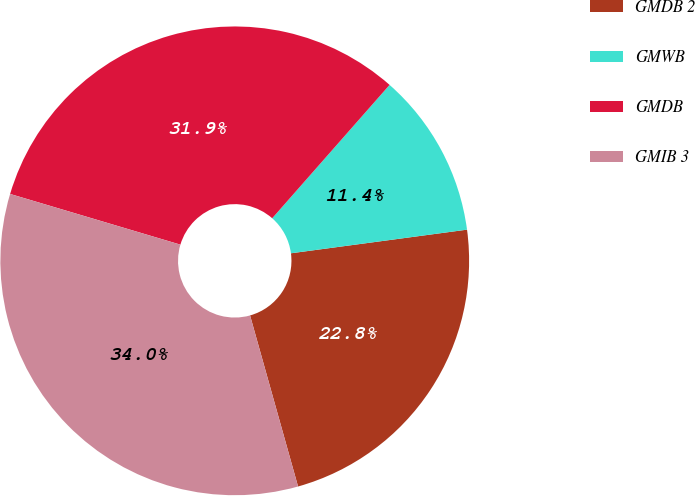Convert chart to OTSL. <chart><loc_0><loc_0><loc_500><loc_500><pie_chart><fcel>GMDB 2<fcel>GMWB<fcel>GMDB<fcel>GMIB 3<nl><fcel>22.77%<fcel>11.39%<fcel>31.88%<fcel>33.96%<nl></chart> 